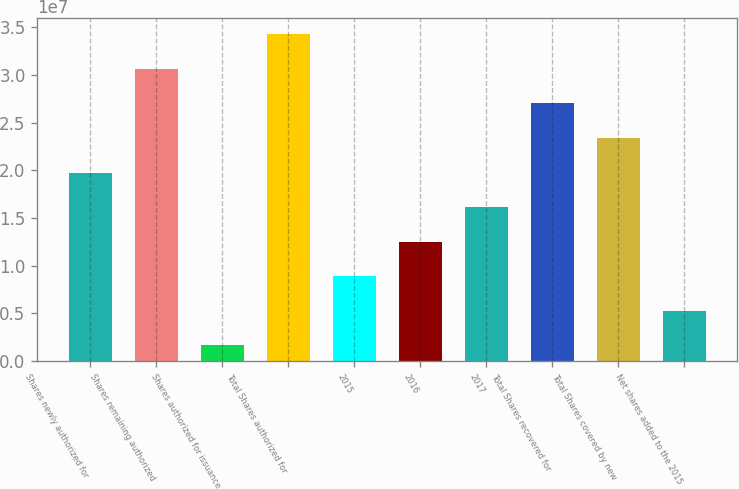<chart> <loc_0><loc_0><loc_500><loc_500><bar_chart><fcel>Shares newly authorized for<fcel>Shares remaining authorized<fcel>Shares authorized for issuance<fcel>Total Shares authorized for<fcel>2015<fcel>2016<fcel>2017<fcel>Total Shares recovered for<fcel>Total Shares covered by new<fcel>Net shares added to the 2015<nl><fcel>1.97558e+07<fcel>3.0624e+07<fcel>1.64221e+06<fcel>3.42467e+07<fcel>8.88765e+06<fcel>1.25104e+07<fcel>1.61331e+07<fcel>2.70013e+07<fcel>2.33785e+07<fcel>5.26493e+06<nl></chart> 